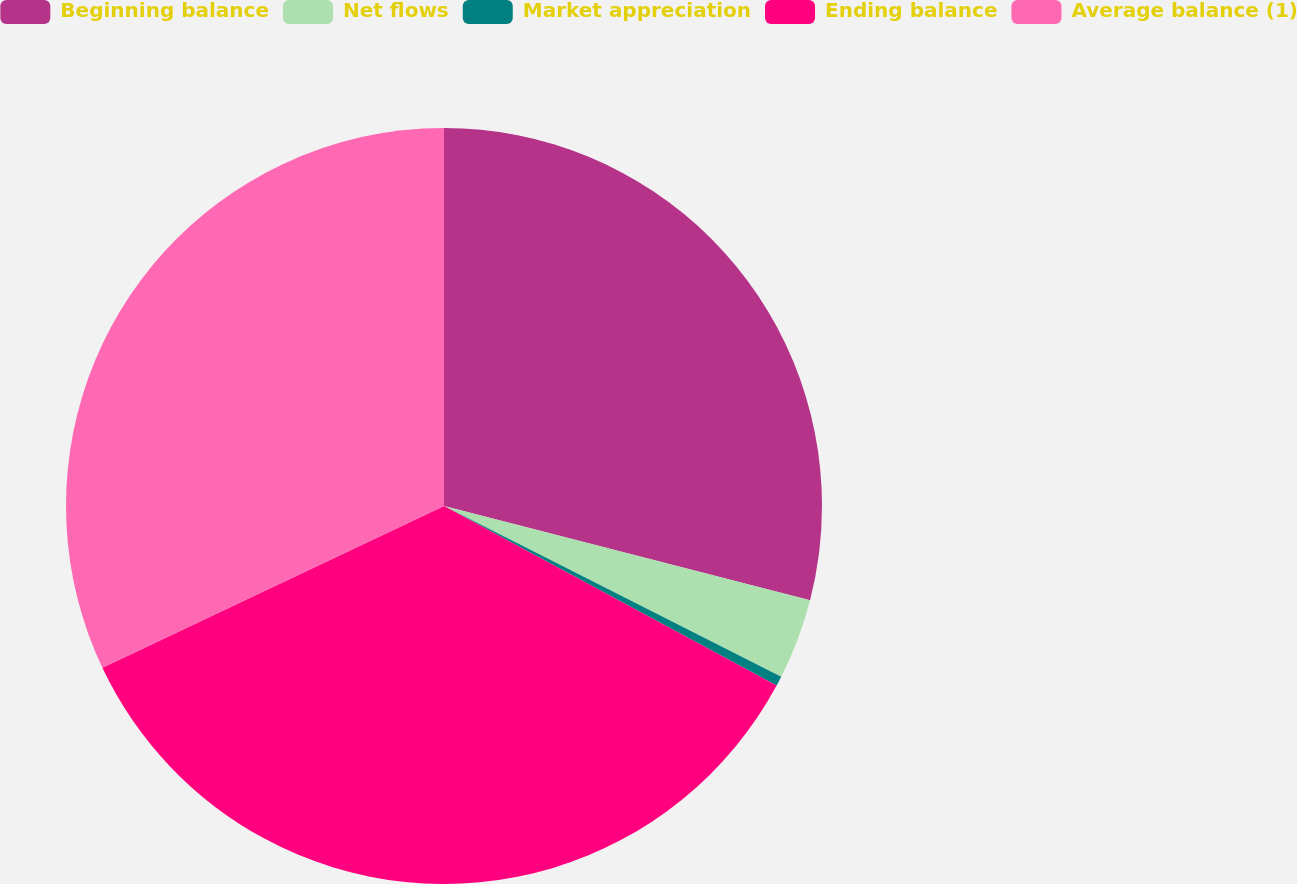Convert chart to OTSL. <chart><loc_0><loc_0><loc_500><loc_500><pie_chart><fcel>Beginning balance<fcel>Net flows<fcel>Market appreciation<fcel>Ending balance<fcel>Average balance (1)<nl><fcel>29.01%<fcel>3.45%<fcel>0.42%<fcel>35.08%<fcel>32.04%<nl></chart> 